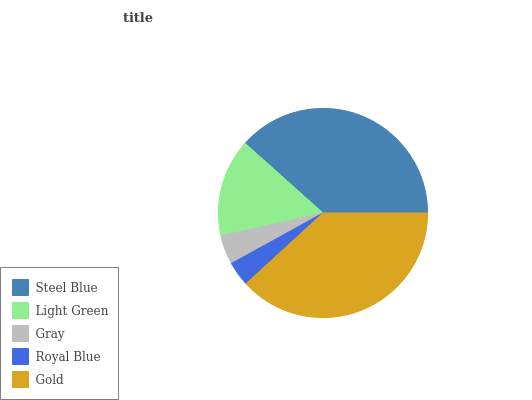Is Royal Blue the minimum?
Answer yes or no. Yes. Is Steel Blue the maximum?
Answer yes or no. Yes. Is Light Green the minimum?
Answer yes or no. No. Is Light Green the maximum?
Answer yes or no. No. Is Steel Blue greater than Light Green?
Answer yes or no. Yes. Is Light Green less than Steel Blue?
Answer yes or no. Yes. Is Light Green greater than Steel Blue?
Answer yes or no. No. Is Steel Blue less than Light Green?
Answer yes or no. No. Is Light Green the high median?
Answer yes or no. Yes. Is Light Green the low median?
Answer yes or no. Yes. Is Royal Blue the high median?
Answer yes or no. No. Is Steel Blue the low median?
Answer yes or no. No. 